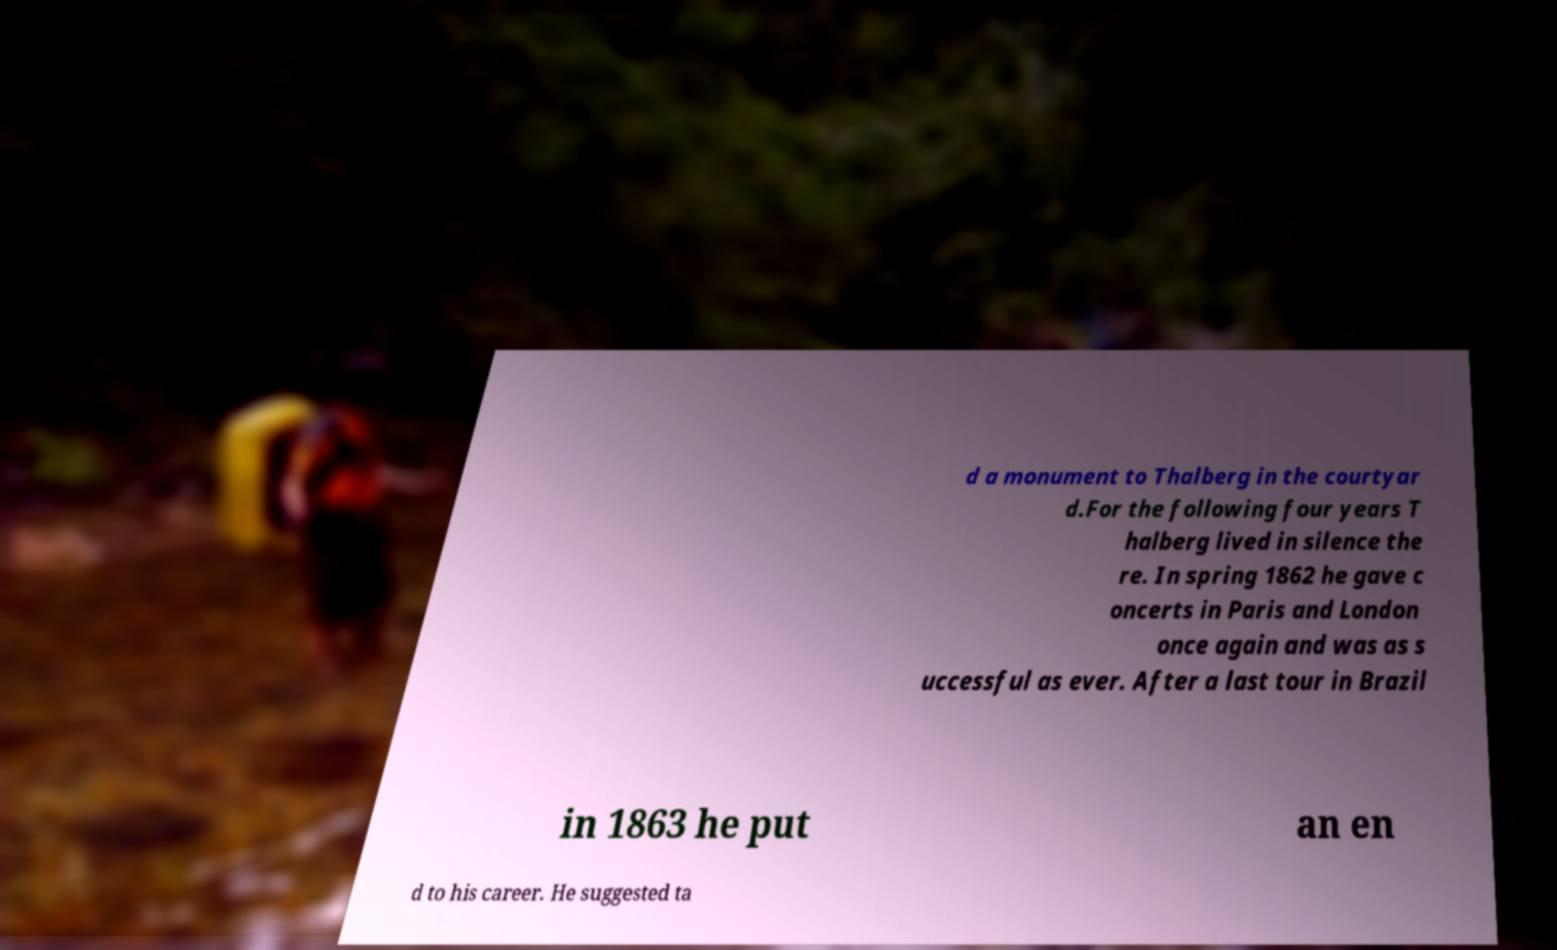Please identify and transcribe the text found in this image. d a monument to Thalberg in the courtyar d.For the following four years T halberg lived in silence the re. In spring 1862 he gave c oncerts in Paris and London once again and was as s uccessful as ever. After a last tour in Brazil in 1863 he put an en d to his career. He suggested ta 